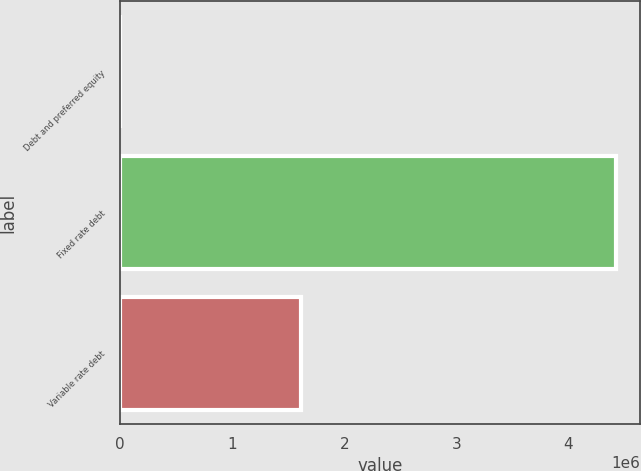Convert chart to OTSL. <chart><loc_0><loc_0><loc_500><loc_500><bar_chart><fcel>Debt and preferred equity<fcel>Fixed rate debt<fcel>Variable rate debt<nl><fcel>2<fcel>4.42187e+06<fcel>1.61222e+06<nl></chart> 